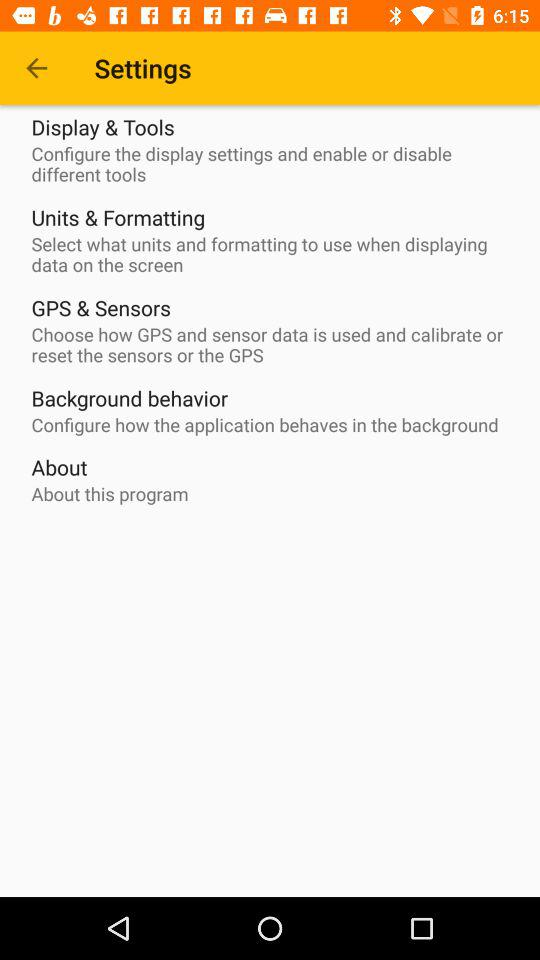How many settings are available in total?
Answer the question using a single word or phrase. 5 